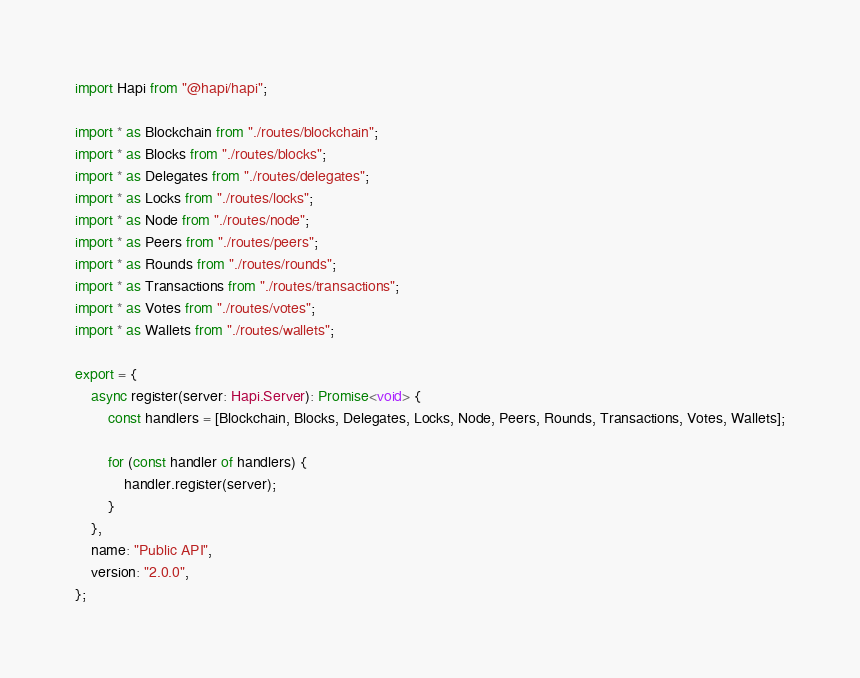Convert code to text. <code><loc_0><loc_0><loc_500><loc_500><_TypeScript_>import Hapi from "@hapi/hapi";

import * as Blockchain from "./routes/blockchain";
import * as Blocks from "./routes/blocks";
import * as Delegates from "./routes/delegates";
import * as Locks from "./routes/locks";
import * as Node from "./routes/node";
import * as Peers from "./routes/peers";
import * as Rounds from "./routes/rounds";
import * as Transactions from "./routes/transactions";
import * as Votes from "./routes/votes";
import * as Wallets from "./routes/wallets";

export = {
    async register(server: Hapi.Server): Promise<void> {
        const handlers = [Blockchain, Blocks, Delegates, Locks, Node, Peers, Rounds, Transactions, Votes, Wallets];

        for (const handler of handlers) {
            handler.register(server);
        }
    },
    name: "Public API",
    version: "2.0.0",
};
</code> 